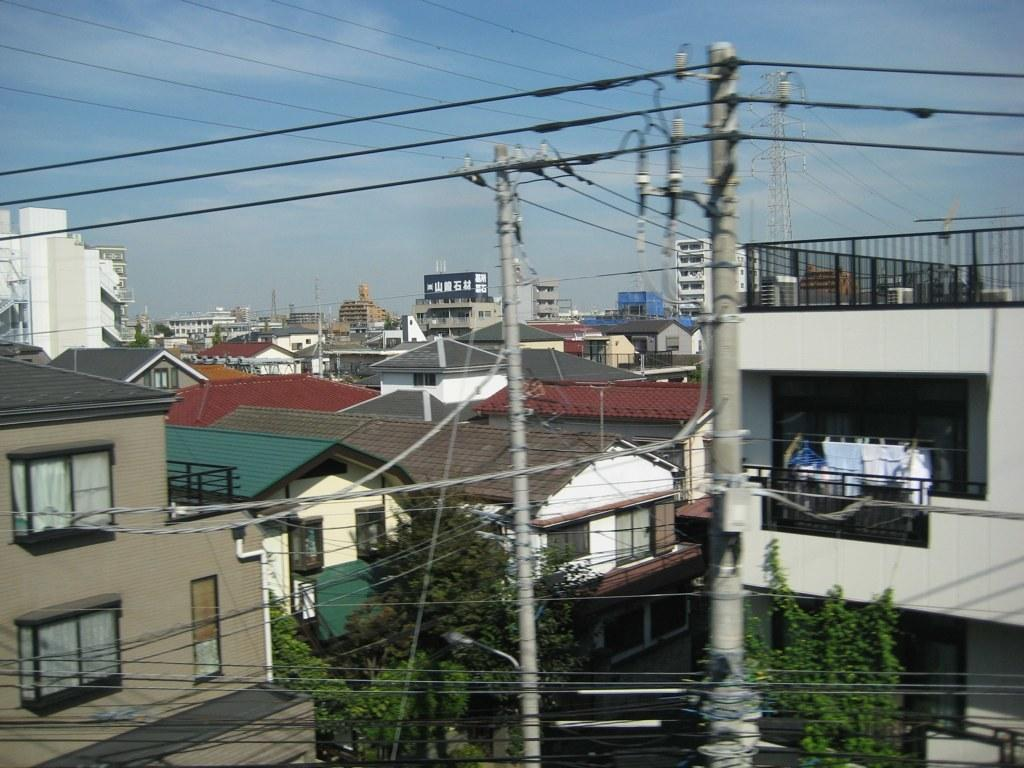What type of structures can be seen in the image? There are buildings in the image. What else can be seen in the image besides buildings? Electric poles with wires and trees are visible in the image. Are there any objects related to daily life in the image? Yes, clothes are present in the image. What is visible in the background of the image? The sky is visible in the background of the image. How many different elements can be identified in the image? There are at least six elements present in the image: buildings, electric poles with wires, trees, clothes, other objects, and the sky. Can you tell me how many receipts are visible in the image? There are no receipts present in the image. What type of engine can be seen in the image? There is no engine present in the image. 